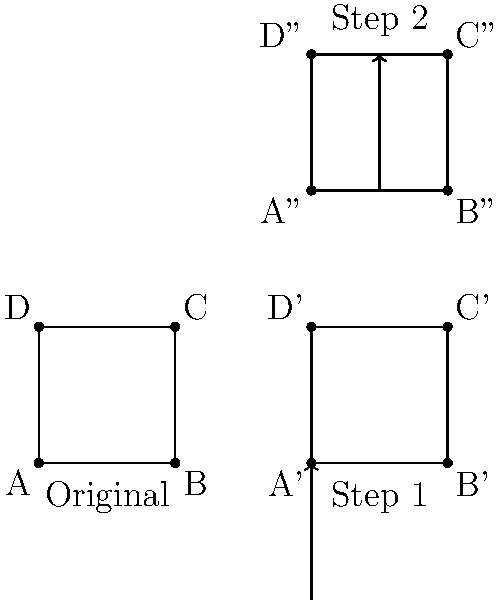As a curator, you've discovered a historical document that has been misoriented through a series of transformations. To display it correctly, you need to reverse these transformations. The document initially underwent a translation of 2 units right, followed by a 90-degree clockwise rotation around the point (2,0), and finally a translation of 4 units up. What sequence of transformations would you apply to restore the document to its original orientation? To reverse the transformations and restore the document to its original orientation, we need to apply the inverse transformations in reverse order:

1) First, we need to undo the translation of 4 units up:
   Apply a translation of 4 units down, T(0, -4)

2) Next, we need to undo the 90-degree clockwise rotation around (2,0):
   Apply a 90-degree counterclockwise rotation around (2,0), R_{(2,0)}(90°)

3) Finally, we need to undo the initial translation of 2 units right:
   Apply a translation of 2 units left, T(-2, 0)

The composition of these transformations can be written as:

$T(-2, 0) \circ R_{(2,0)}(90°) \circ T(0, -4)$

Where $\circ$ denotes composition of transformations, applied from right to left.
Answer: $T(-2, 0) \circ R_{(2,0)}(90°) \circ T(0, -4)$ 